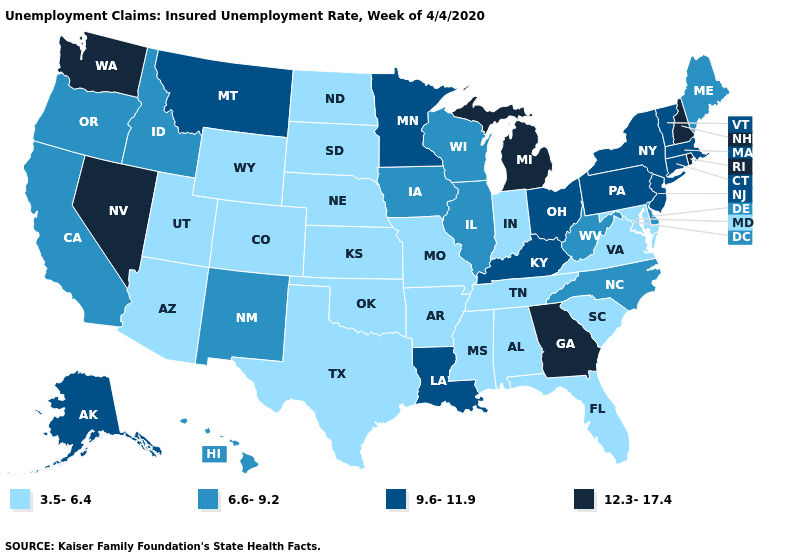What is the value of Oklahoma?
Keep it brief. 3.5-6.4. Does Delaware have a lower value than Pennsylvania?
Keep it brief. Yes. Which states have the lowest value in the West?
Be succinct. Arizona, Colorado, Utah, Wyoming. Name the states that have a value in the range 12.3-17.4?
Quick response, please. Georgia, Michigan, Nevada, New Hampshire, Rhode Island, Washington. What is the lowest value in states that border Kansas?
Answer briefly. 3.5-6.4. What is the lowest value in the West?
Quick response, please. 3.5-6.4. What is the value of Minnesota?
Write a very short answer. 9.6-11.9. What is the lowest value in the Northeast?
Give a very brief answer. 6.6-9.2. What is the highest value in the Northeast ?
Concise answer only. 12.3-17.4. What is the value of Indiana?
Short answer required. 3.5-6.4. Which states have the highest value in the USA?
Write a very short answer. Georgia, Michigan, Nevada, New Hampshire, Rhode Island, Washington. What is the lowest value in states that border Florida?
Be succinct. 3.5-6.4. Which states have the lowest value in the USA?
Keep it brief. Alabama, Arizona, Arkansas, Colorado, Florida, Indiana, Kansas, Maryland, Mississippi, Missouri, Nebraska, North Dakota, Oklahoma, South Carolina, South Dakota, Tennessee, Texas, Utah, Virginia, Wyoming. Among the states that border West Virginia , does Virginia have the lowest value?
Answer briefly. Yes. Among the states that border Washington , which have the lowest value?
Quick response, please. Idaho, Oregon. 